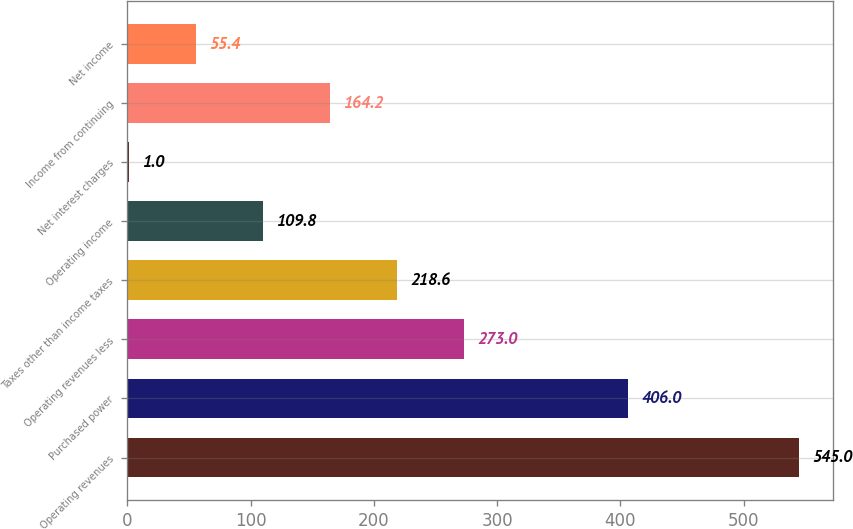<chart> <loc_0><loc_0><loc_500><loc_500><bar_chart><fcel>Operating revenues<fcel>Purchased power<fcel>Operating revenues less<fcel>Taxes other than income taxes<fcel>Operating income<fcel>Net interest charges<fcel>Income from continuing<fcel>Net income<nl><fcel>545<fcel>406<fcel>273<fcel>218.6<fcel>109.8<fcel>1<fcel>164.2<fcel>55.4<nl></chart> 